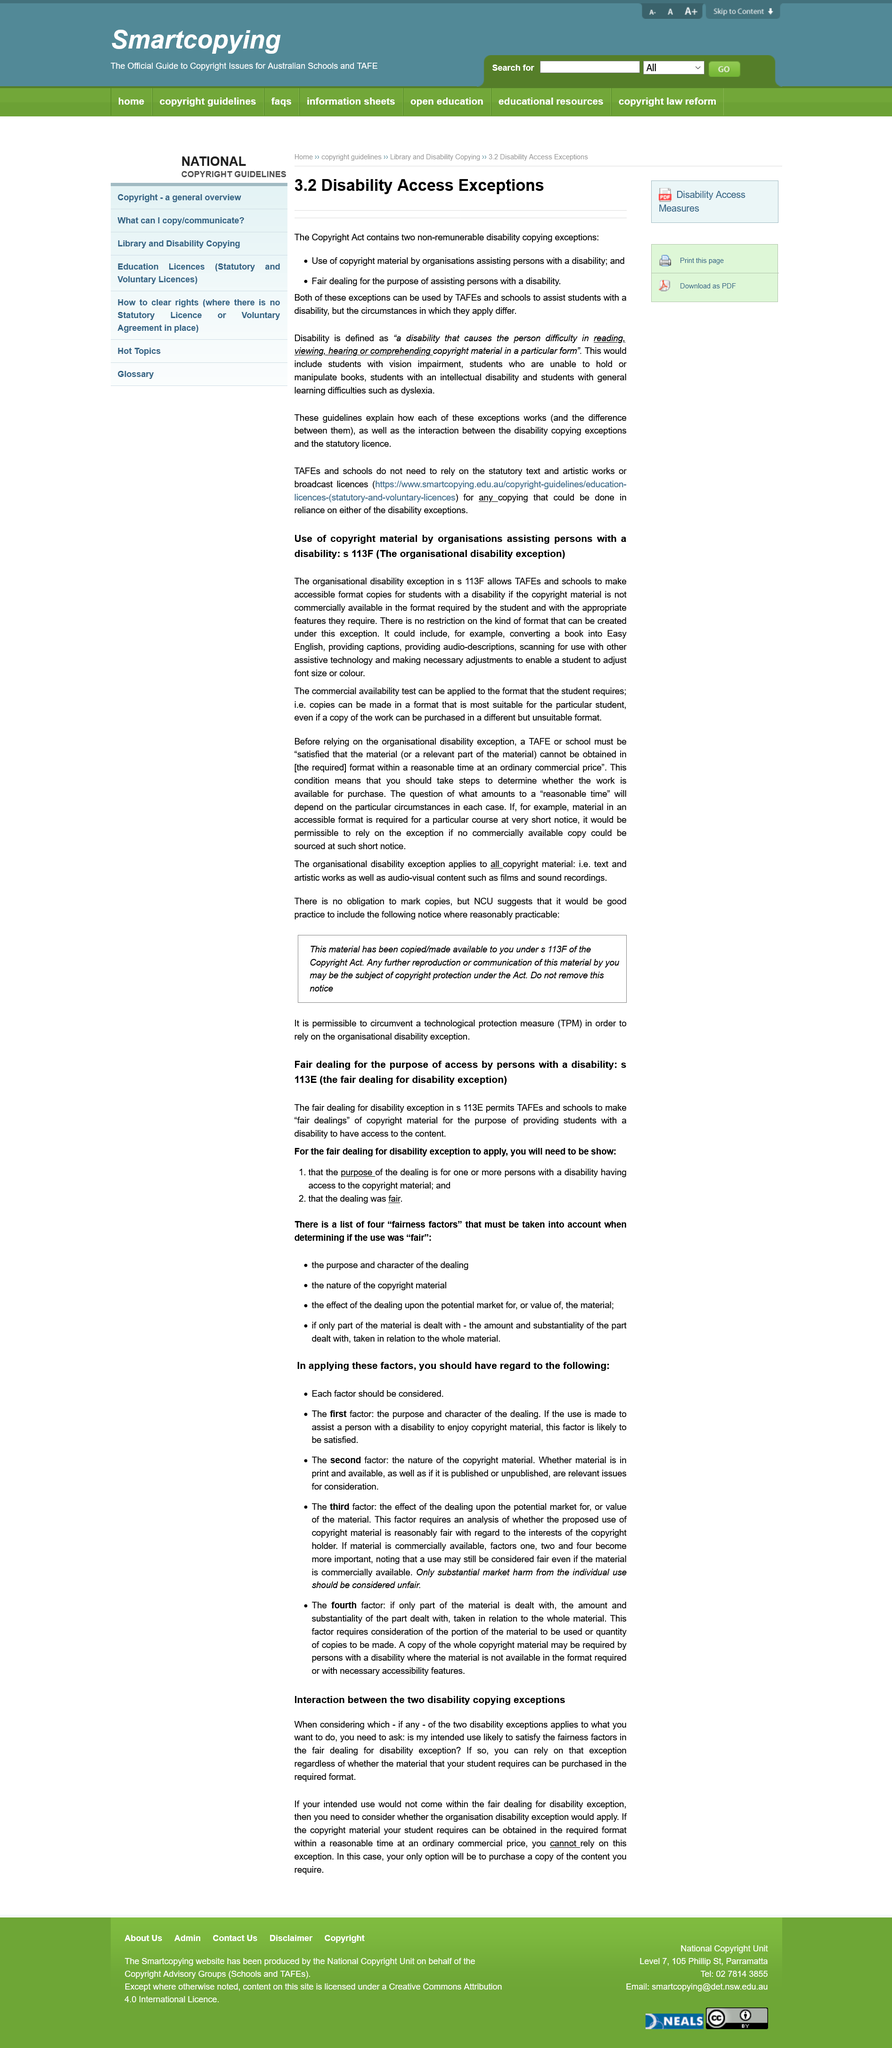Identify some key points in this picture. It is important to consider which, if any, of the two disability expectations applies to my actions and to ask the question of whether my extended use is likely to satisfy the fairness factors in the fair dealing for disability exception in order to ensure that my actions are in compliance with the law. The use of copyright material is evaluated based on whether it falls under one of the four "fairness factors," and if the use is deemed "fair" according to these factors. The "nature of the copyright material" is certainly one of the four factors that must be considered in this determination. It is a disability copying exception to allow for the use of copyrighted material under the fair dealing exception for the purpose of assisting persons with a disability. It is advisable to consider all of the factors when making a decision. There are 4 factors that require your consideration. 